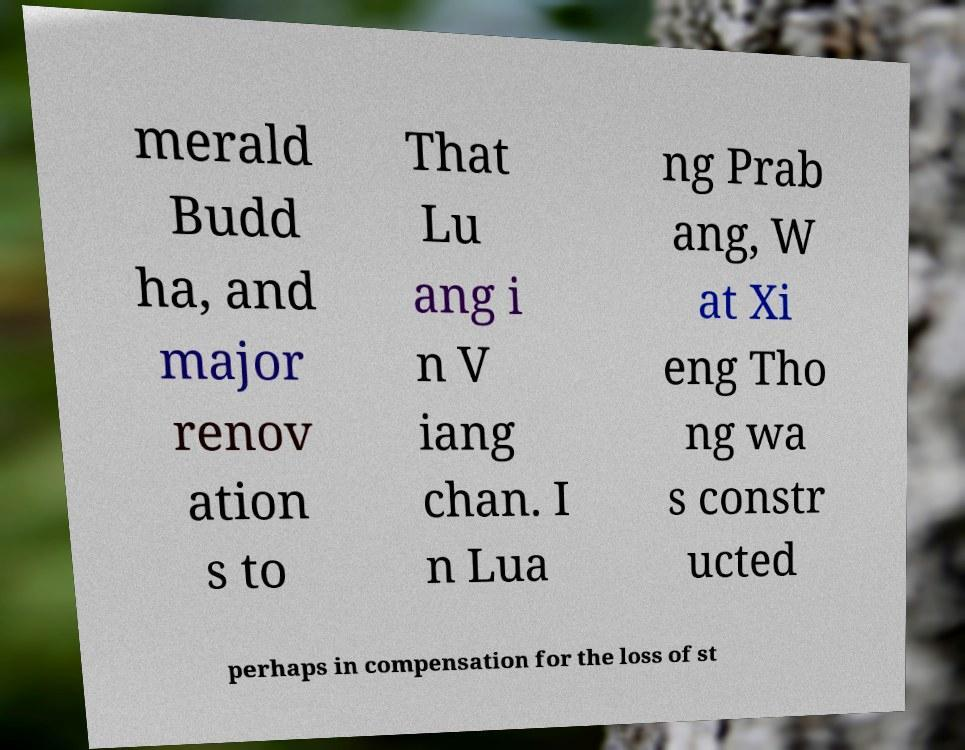Could you assist in decoding the text presented in this image and type it out clearly? merald Budd ha, and major renov ation s to That Lu ang i n V iang chan. I n Lua ng Prab ang, W at Xi eng Tho ng wa s constr ucted perhaps in compensation for the loss of st 